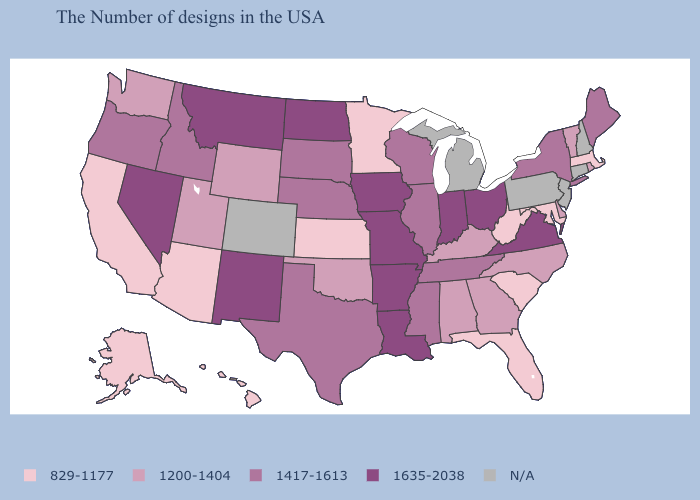Name the states that have a value in the range 1417-1613?
Keep it brief. Maine, New York, Tennessee, Wisconsin, Illinois, Mississippi, Nebraska, Texas, South Dakota, Idaho, Oregon. Name the states that have a value in the range N/A?
Be succinct. New Hampshire, Connecticut, New Jersey, Pennsylvania, Michigan, Colorado. Which states have the lowest value in the MidWest?
Concise answer only. Minnesota, Kansas. What is the value of Pennsylvania?
Write a very short answer. N/A. Name the states that have a value in the range N/A?
Concise answer only. New Hampshire, Connecticut, New Jersey, Pennsylvania, Michigan, Colorado. Does Maine have the highest value in the Northeast?
Give a very brief answer. Yes. Does the first symbol in the legend represent the smallest category?
Give a very brief answer. Yes. Name the states that have a value in the range 1200-1404?
Answer briefly. Rhode Island, Vermont, Delaware, North Carolina, Georgia, Kentucky, Alabama, Oklahoma, Wyoming, Utah, Washington. What is the value of Arkansas?
Answer briefly. 1635-2038. What is the value of Alabama?
Be succinct. 1200-1404. Among the states that border Michigan , which have the highest value?
Write a very short answer. Ohio, Indiana. Name the states that have a value in the range 1200-1404?
Quick response, please. Rhode Island, Vermont, Delaware, North Carolina, Georgia, Kentucky, Alabama, Oklahoma, Wyoming, Utah, Washington. What is the lowest value in the Northeast?
Short answer required. 829-1177. What is the value of Mississippi?
Short answer required. 1417-1613. What is the value of New York?
Quick response, please. 1417-1613. 